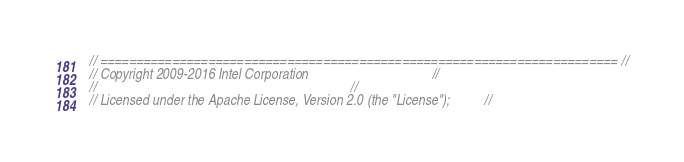Convert code to text. <code><loc_0><loc_0><loc_500><loc_500><_C++_>// ======================================================================== //
// Copyright 2009-2016 Intel Corporation                                    //
//                                                                          //
// Licensed under the Apache License, Version 2.0 (the "License");          //</code> 